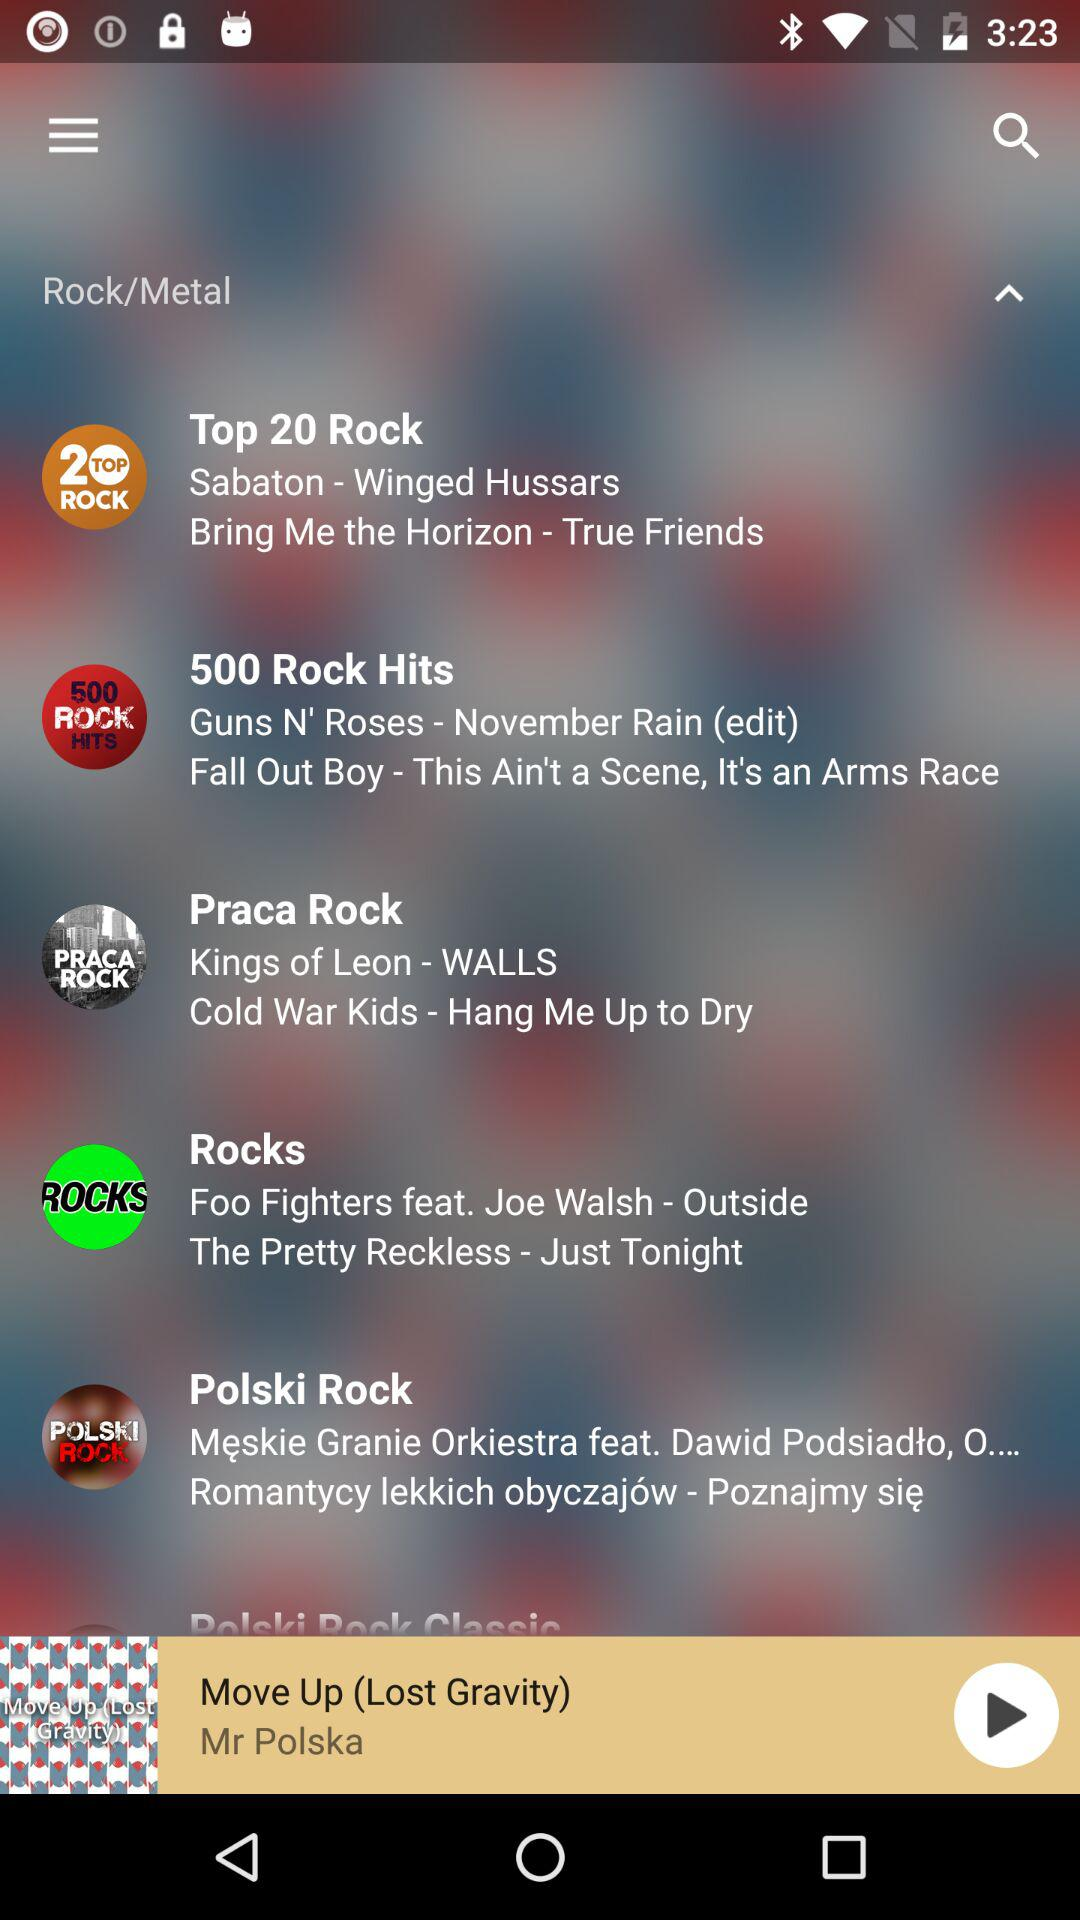Who is the artist of "Move Up"? The artist of "Move Up" is Mr. Polska. 